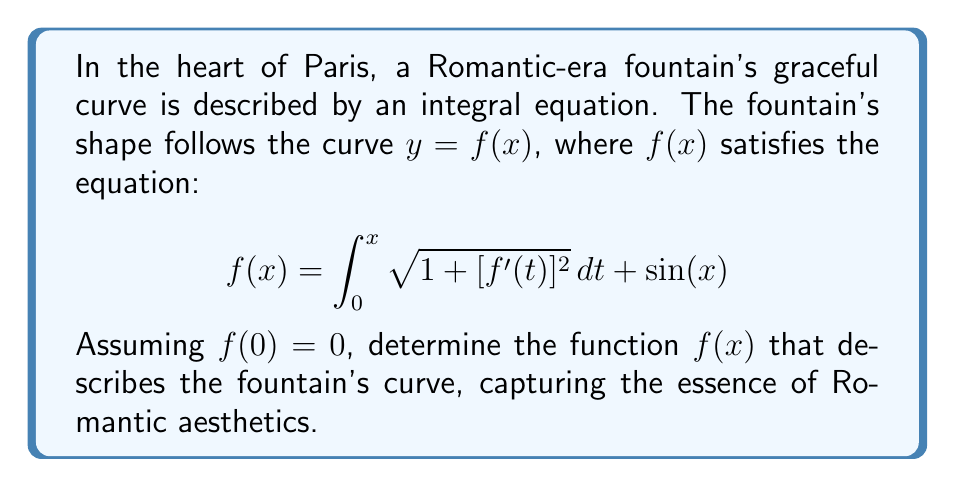Help me with this question. Let's approach this step-by-step:

1) First, we recognize this as a Volterra integral equation of the second kind.

2) The key to solving this is to differentiate both sides with respect to $x$:

   $$\frac{d}{dx}f(x) = \frac{d}{dx}\left(\int_0^x \sqrt{1 + [f'(t)]^2} dt\right) + \frac{d}{dx}\sin(x)$$

3) Using the Fundamental Theorem of Calculus for the integral term:

   $$f'(x) = \sqrt{1 + [f'(x)]^2} + \cos(x)$$

4) Now we have a differential equation. Let's rearrange it:

   $$\sqrt{1 + [f'(x)]^2} = f'(x) - \cos(x)$$

5) Square both sides:

   $$1 + [f'(x)]^2 = [f'(x)]^2 - 2f'(x)\cos(x) + \cos^2(x)$$

6) Simplify:

   $$1 = - 2f'(x)\cos(x) + \cos^2(x)$$

7) Solve for $f'(x)$:

   $$f'(x) = \frac{\cos^2(x) - 1}{2\cos(x)} = \frac{\cos(x)}{2} - \frac{1}{2\cos(x)}$$

8) Integrate both sides:

   $$f(x) = \int \left(\frac{\cos(x)}{2} - \frac{1}{2\cos(x)}\right) dx$$

9) This integrates to:

   $$f(x) = \frac{1}{2}\sin(x) - \frac{1}{2}\ln|\sec(x) + \tan(x)| + C$$

10) Use the initial condition $f(0) = 0$ to find $C$:

    $$0 = 0 - \frac{1}{2}\ln|1 + 0| + C$$
    $$C = 0$$

Therefore, the final solution is:

$$f(x) = \frac{1}{2}\sin(x) - \frac{1}{2}\ln|\sec(x) + \tan(x)|$$
Answer: $f(x) = \frac{1}{2}\sin(x) - \frac{1}{2}\ln|\sec(x) + \tan(x)|$ 